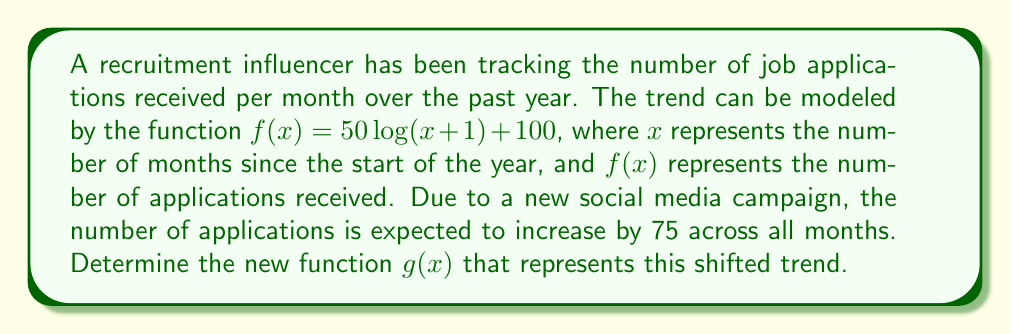Help me with this question. To solve this problem, we need to understand vertical shifts in functions:

1) A vertical shift of a function $f(x)$ by $k$ units upward is represented by $f(x) + k$.

2) In this case, we want to shift the original function upward by 75 units to represent the increase in applications across all months.

3) The original function is $f(x) = 50\log(x+1) + 100$.

4) To shift this function up by 75 units, we add 75 to the entire function:

   $g(x) = f(x) + 75$
   
   $g(x) = [50\log(x+1) + 100] + 75$

5) Simplify by combining like terms:

   $g(x) = 50\log(x+1) + (100 + 75)$
   
   $g(x) = 50\log(x+1) + 175$

This new function $g(x)$ represents the shifted recruitment trend, where the number of applications has increased by 75 across all months.
Answer: $g(x) = 50\log(x+1) + 175$ 